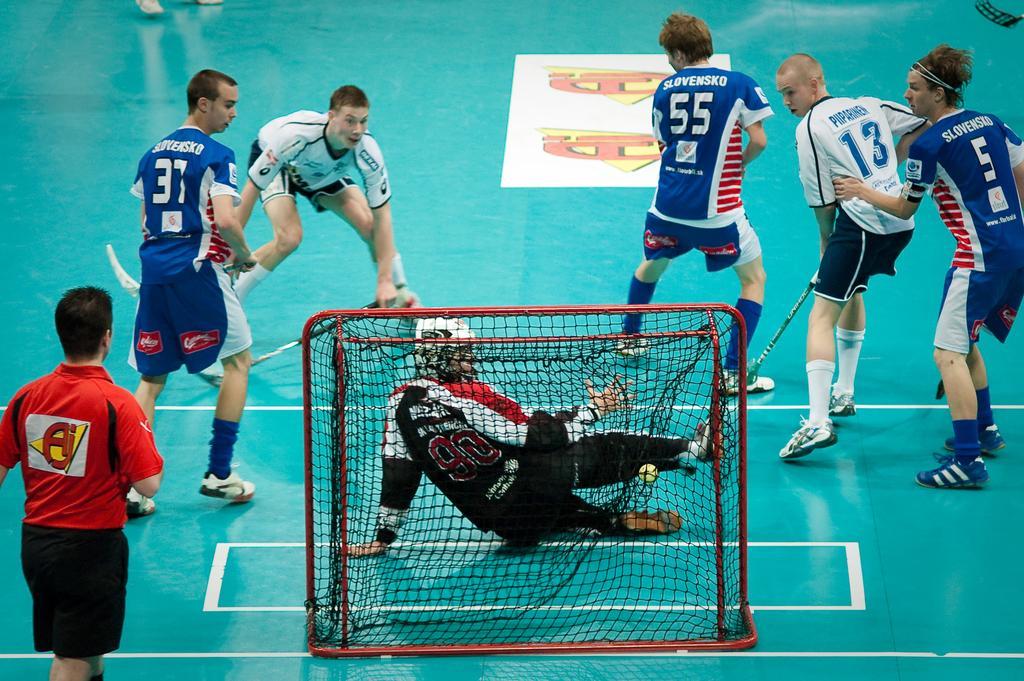Can you describe this image briefly? There are group of boys playing hockey and a net in the background. 